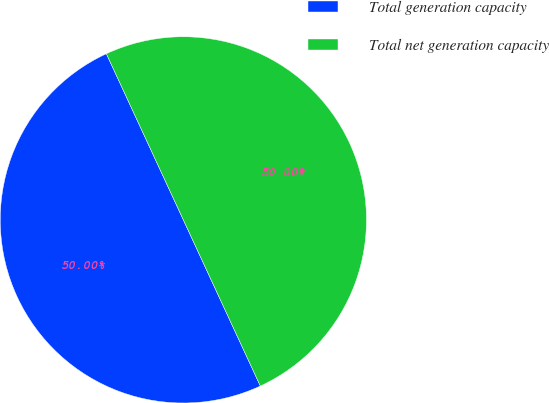<chart> <loc_0><loc_0><loc_500><loc_500><pie_chart><fcel>Total generation capacity<fcel>Total net generation capacity<nl><fcel>50.0%<fcel>50.0%<nl></chart> 